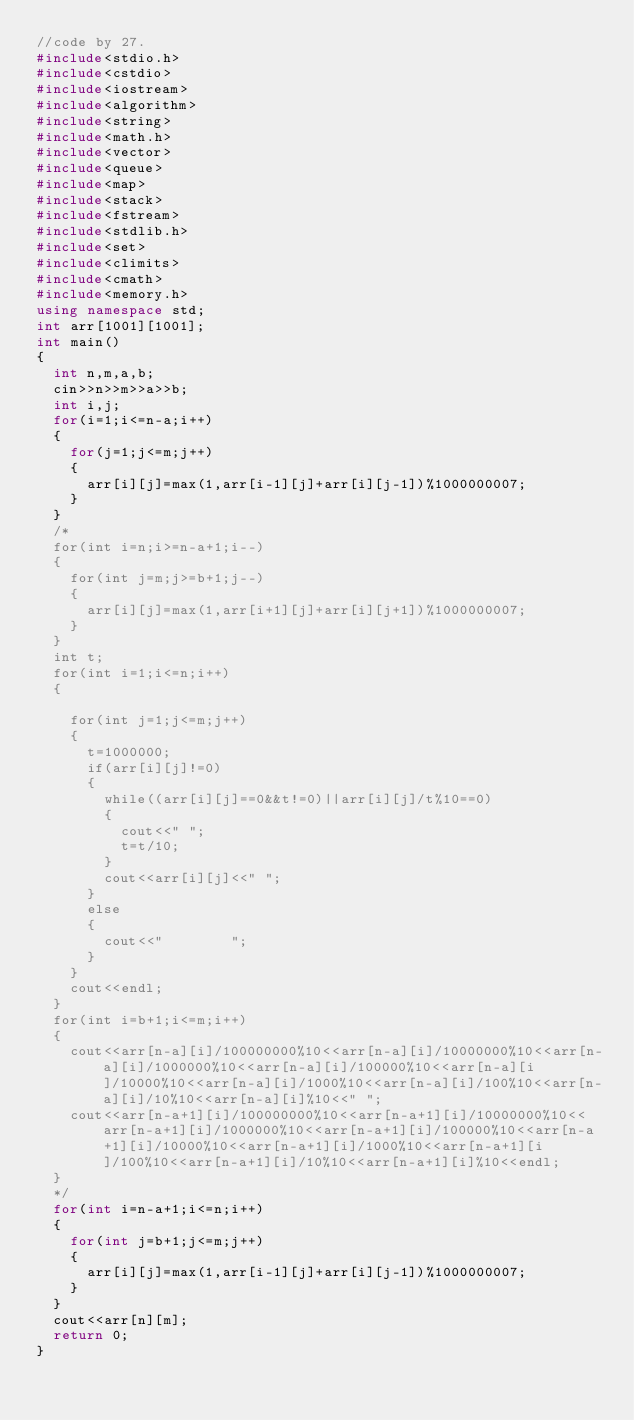<code> <loc_0><loc_0><loc_500><loc_500><_C++_>//code by 27.
#include<stdio.h>
#include<cstdio>
#include<iostream>
#include<algorithm>
#include<string>
#include<math.h>
#include<vector>
#include<queue>
#include<map>
#include<stack>
#include<fstream>
#include<stdlib.h>
#include<set>
#include<climits>
#include<cmath>
#include<memory.h>
using namespace std;
int arr[1001][1001];
int main()
{
	int n,m,a,b;
	cin>>n>>m>>a>>b;
	int i,j;
	for(i=1;i<=n-a;i++)
	{
		for(j=1;j<=m;j++)
		{
			arr[i][j]=max(1,arr[i-1][j]+arr[i][j-1])%1000000007;
		}
	}
	/*
	for(int i=n;i>=n-a+1;i--)
	{
		for(int j=m;j>=b+1;j--)
		{
			arr[i][j]=max(1,arr[i+1][j]+arr[i][j+1])%1000000007;
		}
	}
	int t;
	for(int i=1;i<=n;i++)
	{
		
		for(int j=1;j<=m;j++)
		{
			t=1000000;
			if(arr[i][j]!=0)
			{
				while((arr[i][j]==0&&t!=0)||arr[i][j]/t%10==0)
				{
					cout<<" ";
					t=t/10;
				}
				cout<<arr[i][j]<<" ";
			}
			else
			{
				cout<<"        ";
			}
		}
		cout<<endl;
	}
	for(int i=b+1;i<=m;i++)
	{
		cout<<arr[n-a][i]/100000000%10<<arr[n-a][i]/10000000%10<<arr[n-a][i]/1000000%10<<arr[n-a][i]/100000%10<<arr[n-a][i]/10000%10<<arr[n-a][i]/1000%10<<arr[n-a][i]/100%10<<arr[n-a][i]/10%10<<arr[n-a][i]%10<<" ";
		cout<<arr[n-a+1][i]/100000000%10<<arr[n-a+1][i]/10000000%10<<arr[n-a+1][i]/1000000%10<<arr[n-a+1][i]/100000%10<<arr[n-a+1][i]/10000%10<<arr[n-a+1][i]/1000%10<<arr[n-a+1][i]/100%10<<arr[n-a+1][i]/10%10<<arr[n-a+1][i]%10<<endl;
	}
	*/
	for(int i=n-a+1;i<=n;i++)
	{
		for(int j=b+1;j<=m;j++)
		{
			arr[i][j]=max(1,arr[i-1][j]+arr[i][j-1])%1000000007;
		}
	}
	cout<<arr[n][m];
	return 0;
}</code> 